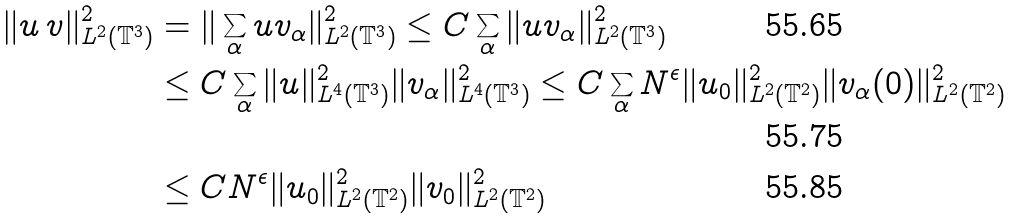Convert formula to latex. <formula><loc_0><loc_0><loc_500><loc_500>\| u \, v \| _ { L ^ { 2 } ( \mathbb { T } ^ { 3 } ) } ^ { 2 } & = \| \sum _ { \alpha } u v _ { \alpha } \| _ { L ^ { 2 } ( \mathbb { T } ^ { 3 } ) } ^ { 2 } \leq C \sum _ { \alpha } \| u v _ { \alpha } \| _ { L ^ { 2 } ( \mathbb { T } ^ { 3 } ) } ^ { 2 } \\ & \leq C \sum _ { \alpha } \| u \| _ { L ^ { 4 } ( \mathbb { T } ^ { 3 } ) } ^ { 2 } \| v _ { \alpha } \| _ { L ^ { 4 } ( \mathbb { T } ^ { 3 } ) } ^ { 2 } \leq C \sum _ { \alpha } N ^ { \epsilon } \| u _ { 0 } \| _ { L ^ { 2 } ( \mathbb { T } ^ { 2 } ) } ^ { 2 } \| v _ { \alpha } ( 0 ) \| _ { L ^ { 2 } ( \mathbb { T } ^ { 2 } ) } ^ { 2 } \\ & \leq C N ^ { \epsilon } \| u _ { 0 } \| _ { L ^ { 2 } ( \mathbb { T } ^ { 2 } ) } ^ { 2 } \| v _ { 0 } \| _ { L ^ { 2 } ( \mathbb { T } ^ { 2 } ) } ^ { 2 }</formula> 